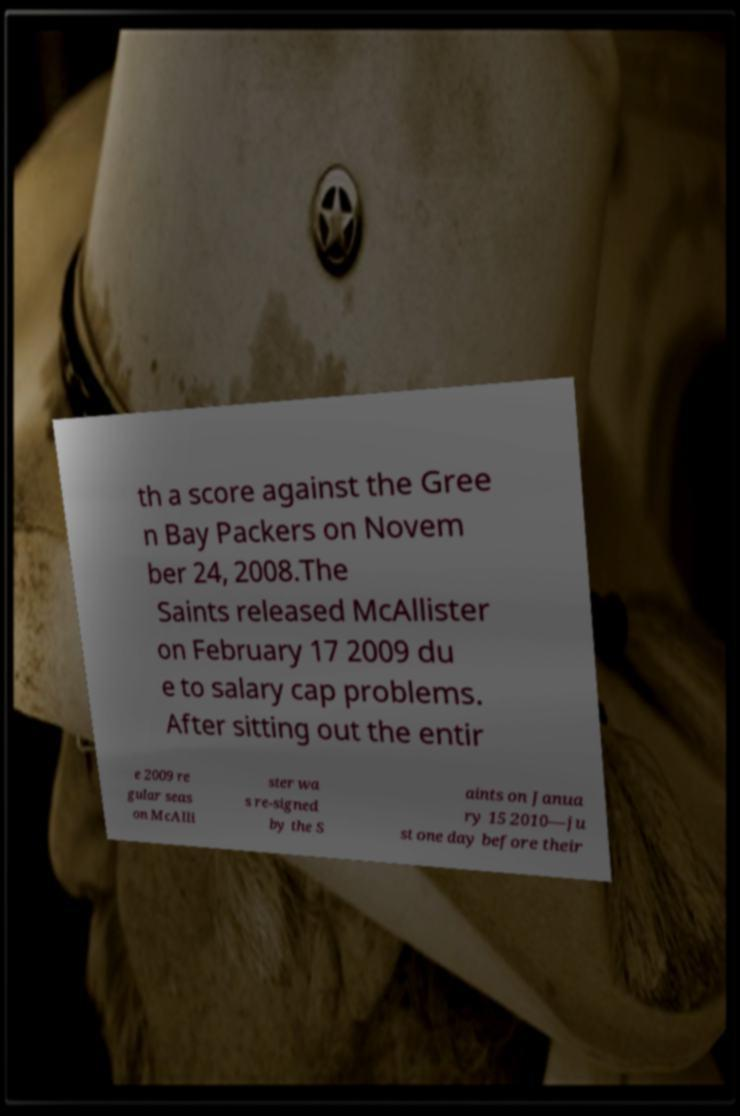Please read and relay the text visible in this image. What does it say? th a score against the Gree n Bay Packers on Novem ber 24, 2008.The Saints released McAllister on February 17 2009 du e to salary cap problems. After sitting out the entir e 2009 re gular seas on McAlli ster wa s re-signed by the S aints on Janua ry 15 2010—ju st one day before their 